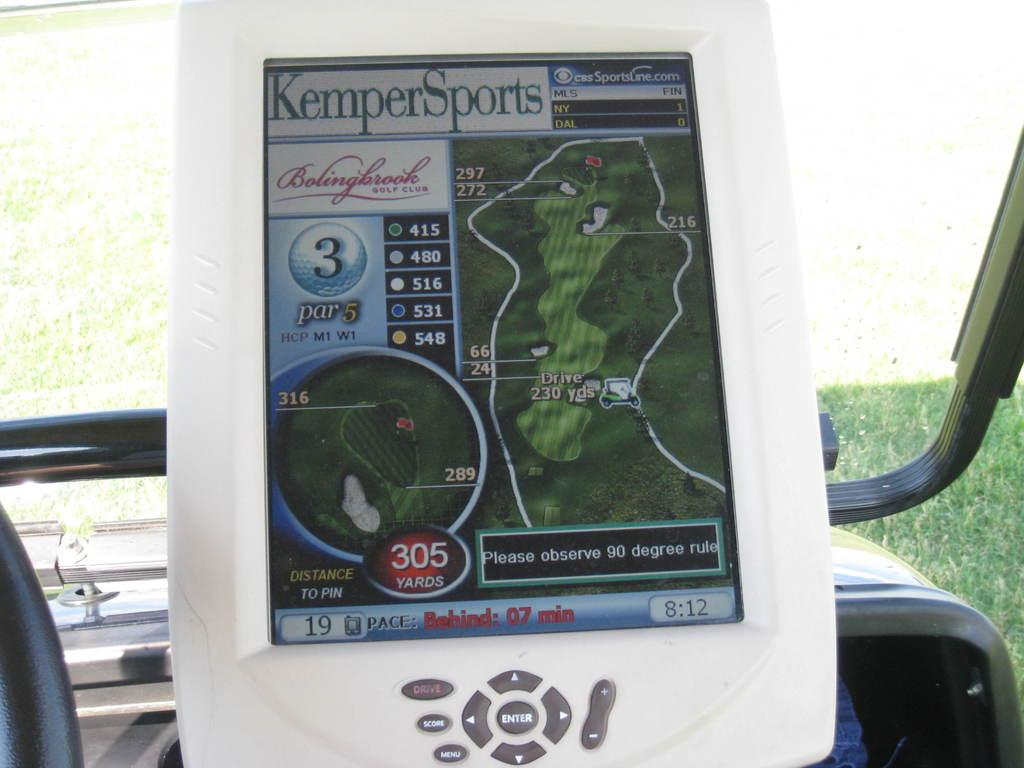Where was the image taken? The image was taken inside a vehicle. What can be seen inside the vehicle? There is a device with buttons and a screen in the vehicle. What can be seen in the background of the image? Grass is visible in the background. Can you see any ink being used in the image? There is no ink visible in the image. Is there a squirrel present in the image? There is no squirrel present in the image. 